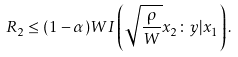Convert formula to latex. <formula><loc_0><loc_0><loc_500><loc_500>R _ { 2 } \leq ( 1 - \alpha ) W I \left ( \sqrt { \frac { \rho } { W } } x _ { 2 } \colon y | x _ { 1 } \right ) .</formula> 